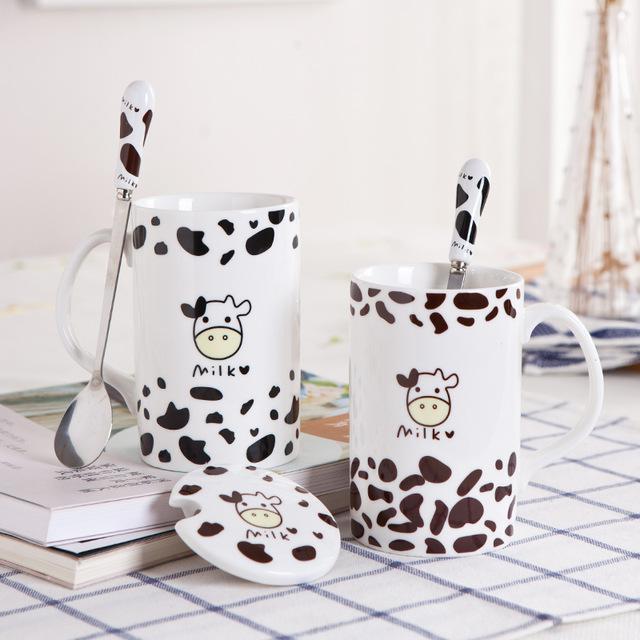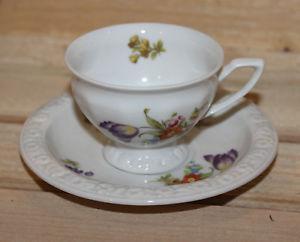The first image is the image on the left, the second image is the image on the right. For the images displayed, is the sentence "In at least one image there are five coffee cups and in the there there is a tea kettle." factually correct? Answer yes or no. No. The first image is the image on the left, the second image is the image on the right. Examine the images to the left and right. Is the description "Some cups are solid colored." accurate? Answer yes or no. No. 